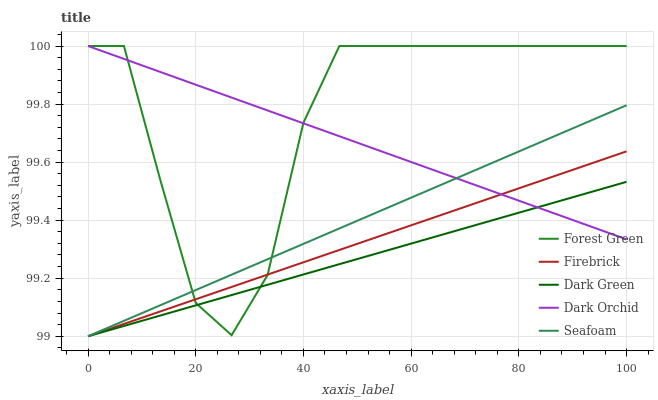Does Dark Green have the minimum area under the curve?
Answer yes or no. Yes. Does Forest Green have the maximum area under the curve?
Answer yes or no. Yes. Does Seafoam have the minimum area under the curve?
Answer yes or no. No. Does Seafoam have the maximum area under the curve?
Answer yes or no. No. Is Dark Green the smoothest?
Answer yes or no. Yes. Is Forest Green the roughest?
Answer yes or no. Yes. Is Seafoam the smoothest?
Answer yes or no. No. Is Seafoam the roughest?
Answer yes or no. No. Does Seafoam have the lowest value?
Answer yes or no. Yes. Does Dark Orchid have the lowest value?
Answer yes or no. No. Does Dark Orchid have the highest value?
Answer yes or no. Yes. Does Seafoam have the highest value?
Answer yes or no. No. Does Seafoam intersect Forest Green?
Answer yes or no. Yes. Is Seafoam less than Forest Green?
Answer yes or no. No. Is Seafoam greater than Forest Green?
Answer yes or no. No. 